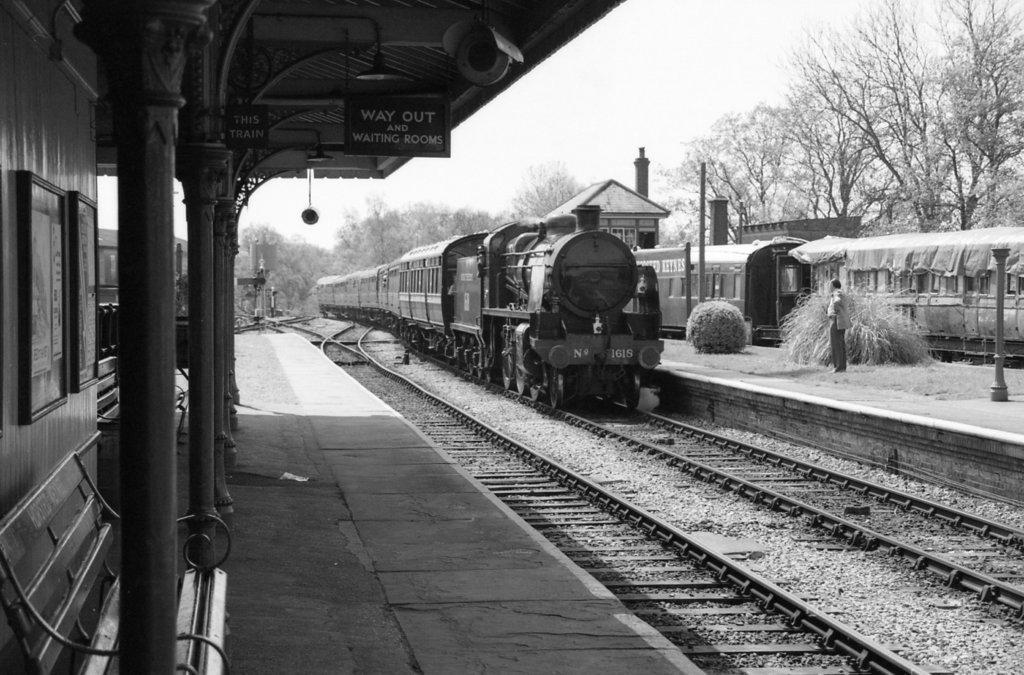Describe this image in one or two sentences. In this picture we can see trains and railway tracks, on the left side there is a platform, a bench and boards, on the right side we can see some trees, poles and a person, there is the sky at the right top of the picture, we can also see trees in the background. 